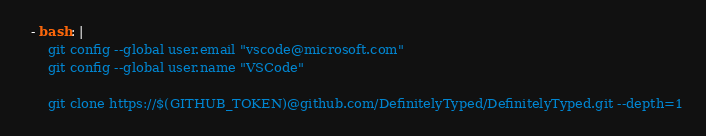<code> <loc_0><loc_0><loc_500><loc_500><_YAML_>
  - bash: |
      git config --global user.email "vscode@microsoft.com"
      git config --global user.name "VSCode"

      git clone https://$(GITHUB_TOKEN)@github.com/DefinitelyTyped/DefinitelyTyped.git --depth=1</code> 